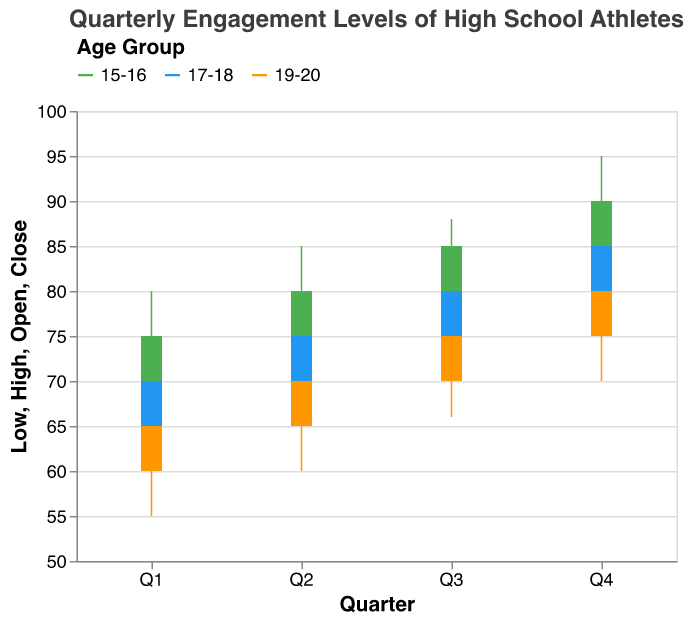What is the title of the chart? The title is at the top of the chart, which clearly states the focus of the data being visualized.
Answer: Quarterly Engagement Levels of High School Athletes How is the age group 15-16 performing in Q4? For the 15-16 age group in Q4, the engagement starts at 85 (Open), reaches a high of 95, drops to a low of 80, and closes at 90.
Answer: The engagement closes at 90 Which age group has the highest closing engagement level in Q2? In Q2, observe the closing engagement levels for each age group. The age group 15-16 closes at 80, 17-18 at 75, and 19-20 at 70.
Answer: Age group 15-16 What is the range of engagement levels for age group 19-20 in Q3? For age group 19-20 in Q3, the low is 66 and the high is 78. The range is calculated by subtracting the low from the high.
Answer: 12 How does the engagement level change from Q1 to Q4 for age group 17-18? For age group 17-18, the opening value in Q1 is 65 and the closing value in Q4 is 85. To understand how engagement changes, we evaluate the difference between these two values.
Answer: It increases by 20 points Which quarter had the highest volatility in engagement levels for age group 15-16? Volatility is seen in the differences between the high and low values. For 15-16: Q1 (15), Q2 (15), Q3 (11), Q4 (15). Q1, Q2, and Q4 have the same highest volatility.
Answer: Q1, Q2, and Q4 Does the age group 19-20 ever reach the engagement level of 85? By observing the highest values for 19-20 in each quarter: Q1 (70), Q2 (73), Q3 (78), Q4 (85), we see it reaches 85 in Q4.
Answer: Yes Compare the closing engagement levels in Q3 for all age groups. Which is the highest? For Q3: 15-16 has 85, 17-18 has 80, and 19-20 has 75. The highest value among these is for 15-16.
Answer: Age group 15-16 What is the average closing engagement level across all age groups in Q1? Closing levels in Q1: 15-16 has 75, 17-18 has 70, and 19-20 has 65. Sum these values and divide by 3 to find the average. (75 + 70 + 65) / 3 = 70.
Answer: 70 